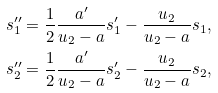Convert formula to latex. <formula><loc_0><loc_0><loc_500><loc_500>s _ { 1 } ^ { \prime \prime } = \frac { 1 } { 2 } \frac { a ^ { \prime } } { u _ { 2 } - a } s _ { 1 } ^ { \prime } - \frac { u _ { 2 } } { u _ { 2 } - a } s _ { 1 } , \\ s _ { 2 } ^ { \prime \prime } = \frac { 1 } { 2 } \frac { a ^ { \prime } } { u _ { 2 } - a } s _ { 2 } ^ { \prime } - \frac { u _ { 2 } } { u _ { 2 } - a } s _ { 2 } ,</formula> 